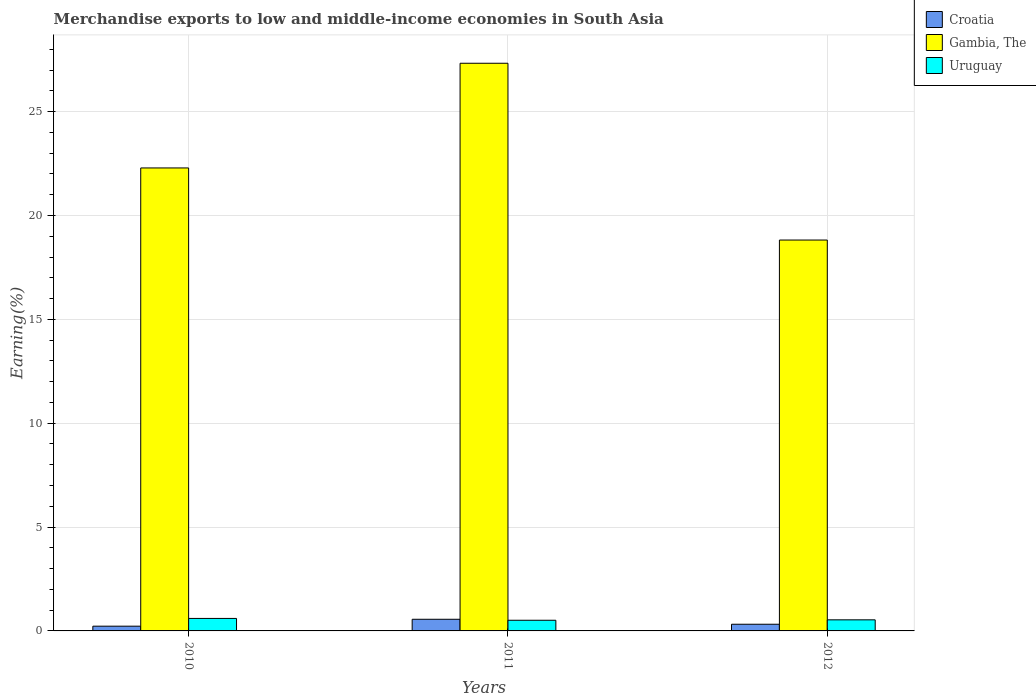How many different coloured bars are there?
Provide a succinct answer. 3. How many bars are there on the 2nd tick from the left?
Keep it short and to the point. 3. What is the label of the 1st group of bars from the left?
Make the answer very short. 2010. In how many cases, is the number of bars for a given year not equal to the number of legend labels?
Provide a succinct answer. 0. What is the percentage of amount earned from merchandise exports in Croatia in 2012?
Make the answer very short. 0.32. Across all years, what is the maximum percentage of amount earned from merchandise exports in Gambia, The?
Your answer should be very brief. 27.33. Across all years, what is the minimum percentage of amount earned from merchandise exports in Gambia, The?
Your response must be concise. 18.82. What is the total percentage of amount earned from merchandise exports in Uruguay in the graph?
Your answer should be very brief. 1.65. What is the difference between the percentage of amount earned from merchandise exports in Gambia, The in 2011 and that in 2012?
Make the answer very short. 8.51. What is the difference between the percentage of amount earned from merchandise exports in Gambia, The in 2011 and the percentage of amount earned from merchandise exports in Uruguay in 2010?
Your answer should be very brief. 26.73. What is the average percentage of amount earned from merchandise exports in Uruguay per year?
Make the answer very short. 0.55. In the year 2010, what is the difference between the percentage of amount earned from merchandise exports in Croatia and percentage of amount earned from merchandise exports in Gambia, The?
Provide a succinct answer. -22.06. What is the ratio of the percentage of amount earned from merchandise exports in Gambia, The in 2010 to that in 2012?
Give a very brief answer. 1.18. Is the percentage of amount earned from merchandise exports in Gambia, The in 2011 less than that in 2012?
Give a very brief answer. No. What is the difference between the highest and the second highest percentage of amount earned from merchandise exports in Croatia?
Offer a terse response. 0.24. What is the difference between the highest and the lowest percentage of amount earned from merchandise exports in Croatia?
Your answer should be compact. 0.33. What does the 2nd bar from the left in 2011 represents?
Provide a succinct answer. Gambia, The. What does the 3rd bar from the right in 2012 represents?
Provide a succinct answer. Croatia. What is the difference between two consecutive major ticks on the Y-axis?
Ensure brevity in your answer.  5. Does the graph contain any zero values?
Offer a terse response. No. Where does the legend appear in the graph?
Ensure brevity in your answer.  Top right. What is the title of the graph?
Provide a short and direct response. Merchandise exports to low and middle-income economies in South Asia. What is the label or title of the Y-axis?
Give a very brief answer. Earning(%). What is the Earning(%) of Croatia in 2010?
Ensure brevity in your answer.  0.23. What is the Earning(%) of Gambia, The in 2010?
Your response must be concise. 22.29. What is the Earning(%) of Uruguay in 2010?
Offer a very short reply. 0.6. What is the Earning(%) of Croatia in 2011?
Offer a terse response. 0.56. What is the Earning(%) in Gambia, The in 2011?
Offer a terse response. 27.33. What is the Earning(%) in Uruguay in 2011?
Offer a terse response. 0.51. What is the Earning(%) in Croatia in 2012?
Offer a very short reply. 0.32. What is the Earning(%) in Gambia, The in 2012?
Provide a short and direct response. 18.82. What is the Earning(%) in Uruguay in 2012?
Offer a very short reply. 0.53. Across all years, what is the maximum Earning(%) in Croatia?
Your answer should be very brief. 0.56. Across all years, what is the maximum Earning(%) in Gambia, The?
Your answer should be compact. 27.33. Across all years, what is the maximum Earning(%) of Uruguay?
Provide a short and direct response. 0.6. Across all years, what is the minimum Earning(%) of Croatia?
Ensure brevity in your answer.  0.23. Across all years, what is the minimum Earning(%) in Gambia, The?
Ensure brevity in your answer.  18.82. Across all years, what is the minimum Earning(%) of Uruguay?
Your answer should be very brief. 0.51. What is the total Earning(%) in Croatia in the graph?
Your answer should be compact. 1.11. What is the total Earning(%) of Gambia, The in the graph?
Offer a terse response. 68.44. What is the total Earning(%) in Uruguay in the graph?
Give a very brief answer. 1.65. What is the difference between the Earning(%) of Croatia in 2010 and that in 2011?
Keep it short and to the point. -0.33. What is the difference between the Earning(%) of Gambia, The in 2010 and that in 2011?
Provide a short and direct response. -5.04. What is the difference between the Earning(%) of Uruguay in 2010 and that in 2011?
Your answer should be very brief. 0.09. What is the difference between the Earning(%) in Croatia in 2010 and that in 2012?
Keep it short and to the point. -0.09. What is the difference between the Earning(%) of Gambia, The in 2010 and that in 2012?
Keep it short and to the point. 3.47. What is the difference between the Earning(%) in Uruguay in 2010 and that in 2012?
Your response must be concise. 0.07. What is the difference between the Earning(%) of Croatia in 2011 and that in 2012?
Offer a very short reply. 0.24. What is the difference between the Earning(%) of Gambia, The in 2011 and that in 2012?
Make the answer very short. 8.51. What is the difference between the Earning(%) in Uruguay in 2011 and that in 2012?
Offer a terse response. -0.02. What is the difference between the Earning(%) in Croatia in 2010 and the Earning(%) in Gambia, The in 2011?
Your answer should be very brief. -27.1. What is the difference between the Earning(%) of Croatia in 2010 and the Earning(%) of Uruguay in 2011?
Offer a terse response. -0.28. What is the difference between the Earning(%) of Gambia, The in 2010 and the Earning(%) of Uruguay in 2011?
Offer a terse response. 21.78. What is the difference between the Earning(%) in Croatia in 2010 and the Earning(%) in Gambia, The in 2012?
Your response must be concise. -18.59. What is the difference between the Earning(%) in Croatia in 2010 and the Earning(%) in Uruguay in 2012?
Provide a short and direct response. -0.31. What is the difference between the Earning(%) in Gambia, The in 2010 and the Earning(%) in Uruguay in 2012?
Make the answer very short. 21.76. What is the difference between the Earning(%) in Croatia in 2011 and the Earning(%) in Gambia, The in 2012?
Ensure brevity in your answer.  -18.26. What is the difference between the Earning(%) in Croatia in 2011 and the Earning(%) in Uruguay in 2012?
Offer a very short reply. 0.03. What is the difference between the Earning(%) in Gambia, The in 2011 and the Earning(%) in Uruguay in 2012?
Keep it short and to the point. 26.8. What is the average Earning(%) in Croatia per year?
Make the answer very short. 0.37. What is the average Earning(%) of Gambia, The per year?
Your response must be concise. 22.81. What is the average Earning(%) of Uruguay per year?
Provide a short and direct response. 0.55. In the year 2010, what is the difference between the Earning(%) in Croatia and Earning(%) in Gambia, The?
Provide a succinct answer. -22.06. In the year 2010, what is the difference between the Earning(%) of Croatia and Earning(%) of Uruguay?
Offer a very short reply. -0.37. In the year 2010, what is the difference between the Earning(%) in Gambia, The and Earning(%) in Uruguay?
Your answer should be compact. 21.69. In the year 2011, what is the difference between the Earning(%) in Croatia and Earning(%) in Gambia, The?
Provide a short and direct response. -26.77. In the year 2011, what is the difference between the Earning(%) in Croatia and Earning(%) in Uruguay?
Offer a terse response. 0.05. In the year 2011, what is the difference between the Earning(%) of Gambia, The and Earning(%) of Uruguay?
Your response must be concise. 26.82. In the year 2012, what is the difference between the Earning(%) in Croatia and Earning(%) in Gambia, The?
Provide a short and direct response. -18.5. In the year 2012, what is the difference between the Earning(%) in Croatia and Earning(%) in Uruguay?
Your answer should be very brief. -0.21. In the year 2012, what is the difference between the Earning(%) of Gambia, The and Earning(%) of Uruguay?
Offer a terse response. 18.28. What is the ratio of the Earning(%) in Croatia in 2010 to that in 2011?
Your response must be concise. 0.41. What is the ratio of the Earning(%) in Gambia, The in 2010 to that in 2011?
Keep it short and to the point. 0.82. What is the ratio of the Earning(%) in Uruguay in 2010 to that in 2011?
Give a very brief answer. 1.17. What is the ratio of the Earning(%) of Croatia in 2010 to that in 2012?
Give a very brief answer. 0.71. What is the ratio of the Earning(%) of Gambia, The in 2010 to that in 2012?
Offer a very short reply. 1.18. What is the ratio of the Earning(%) of Uruguay in 2010 to that in 2012?
Your response must be concise. 1.13. What is the ratio of the Earning(%) of Croatia in 2011 to that in 2012?
Your answer should be compact. 1.74. What is the ratio of the Earning(%) in Gambia, The in 2011 to that in 2012?
Ensure brevity in your answer.  1.45. What is the ratio of the Earning(%) of Uruguay in 2011 to that in 2012?
Your response must be concise. 0.96. What is the difference between the highest and the second highest Earning(%) of Croatia?
Provide a short and direct response. 0.24. What is the difference between the highest and the second highest Earning(%) in Gambia, The?
Ensure brevity in your answer.  5.04. What is the difference between the highest and the second highest Earning(%) in Uruguay?
Ensure brevity in your answer.  0.07. What is the difference between the highest and the lowest Earning(%) of Croatia?
Your answer should be compact. 0.33. What is the difference between the highest and the lowest Earning(%) in Gambia, The?
Give a very brief answer. 8.51. What is the difference between the highest and the lowest Earning(%) of Uruguay?
Your answer should be compact. 0.09. 